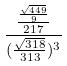<formula> <loc_0><loc_0><loc_500><loc_500>\frac { \frac { \frac { \sqrt { 4 4 9 } } { 9 } } { 2 1 7 } } { ( \frac { \sqrt { 3 1 8 } } { 3 1 3 } ) ^ { 3 } }</formula> 